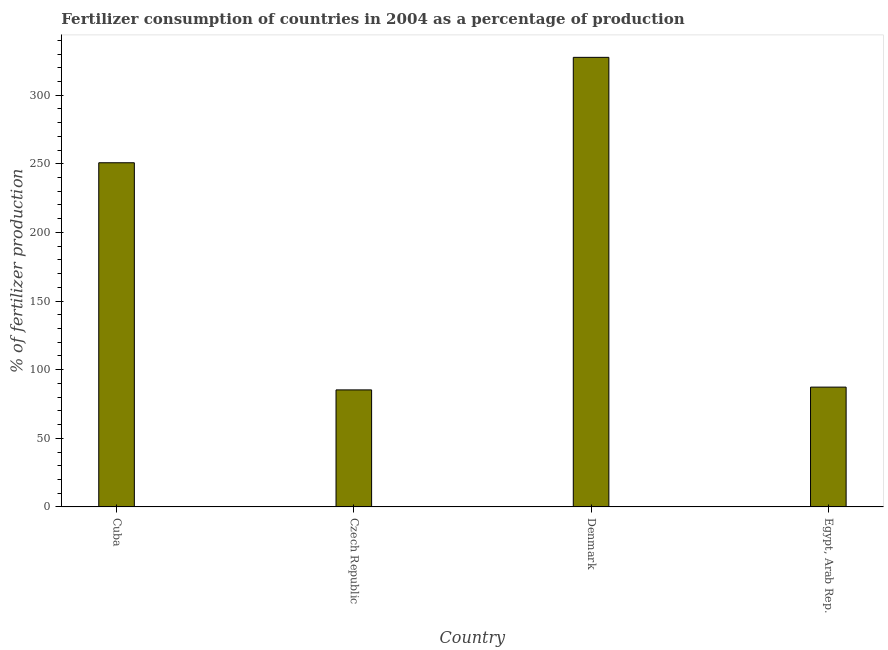Does the graph contain any zero values?
Your answer should be compact. No. What is the title of the graph?
Give a very brief answer. Fertilizer consumption of countries in 2004 as a percentage of production. What is the label or title of the Y-axis?
Provide a short and direct response. % of fertilizer production. What is the amount of fertilizer consumption in Denmark?
Give a very brief answer. 327.58. Across all countries, what is the maximum amount of fertilizer consumption?
Your answer should be compact. 327.58. Across all countries, what is the minimum amount of fertilizer consumption?
Your answer should be very brief. 85.27. In which country was the amount of fertilizer consumption maximum?
Offer a very short reply. Denmark. In which country was the amount of fertilizer consumption minimum?
Provide a short and direct response. Czech Republic. What is the sum of the amount of fertilizer consumption?
Your response must be concise. 750.92. What is the difference between the amount of fertilizer consumption in Cuba and Denmark?
Your answer should be very brief. -76.8. What is the average amount of fertilizer consumption per country?
Your response must be concise. 187.73. What is the median amount of fertilizer consumption?
Your response must be concise. 169.04. In how many countries, is the amount of fertilizer consumption greater than 190 %?
Provide a short and direct response. 2. What is the ratio of the amount of fertilizer consumption in Cuba to that in Denmark?
Provide a succinct answer. 0.77. Is the amount of fertilizer consumption in Cuba less than that in Denmark?
Offer a very short reply. Yes. Is the difference between the amount of fertilizer consumption in Cuba and Denmark greater than the difference between any two countries?
Provide a short and direct response. No. What is the difference between the highest and the second highest amount of fertilizer consumption?
Your response must be concise. 76.8. What is the difference between the highest and the lowest amount of fertilizer consumption?
Keep it short and to the point. 242.31. In how many countries, is the amount of fertilizer consumption greater than the average amount of fertilizer consumption taken over all countries?
Your response must be concise. 2. How many bars are there?
Make the answer very short. 4. Are all the bars in the graph horizontal?
Keep it short and to the point. No. What is the difference between two consecutive major ticks on the Y-axis?
Ensure brevity in your answer.  50. What is the % of fertilizer production in Cuba?
Keep it short and to the point. 250.78. What is the % of fertilizer production of Czech Republic?
Provide a succinct answer. 85.27. What is the % of fertilizer production of Denmark?
Your response must be concise. 327.58. What is the % of fertilizer production of Egypt, Arab Rep.?
Provide a succinct answer. 87.3. What is the difference between the % of fertilizer production in Cuba and Czech Republic?
Make the answer very short. 165.51. What is the difference between the % of fertilizer production in Cuba and Denmark?
Offer a very short reply. -76.8. What is the difference between the % of fertilizer production in Cuba and Egypt, Arab Rep.?
Your answer should be compact. 163.48. What is the difference between the % of fertilizer production in Czech Republic and Denmark?
Your answer should be compact. -242.31. What is the difference between the % of fertilizer production in Czech Republic and Egypt, Arab Rep.?
Provide a short and direct response. -2.03. What is the difference between the % of fertilizer production in Denmark and Egypt, Arab Rep.?
Make the answer very short. 240.28. What is the ratio of the % of fertilizer production in Cuba to that in Czech Republic?
Provide a short and direct response. 2.94. What is the ratio of the % of fertilizer production in Cuba to that in Denmark?
Keep it short and to the point. 0.77. What is the ratio of the % of fertilizer production in Cuba to that in Egypt, Arab Rep.?
Your answer should be compact. 2.87. What is the ratio of the % of fertilizer production in Czech Republic to that in Denmark?
Provide a succinct answer. 0.26. What is the ratio of the % of fertilizer production in Czech Republic to that in Egypt, Arab Rep.?
Your answer should be very brief. 0.98. What is the ratio of the % of fertilizer production in Denmark to that in Egypt, Arab Rep.?
Keep it short and to the point. 3.75. 